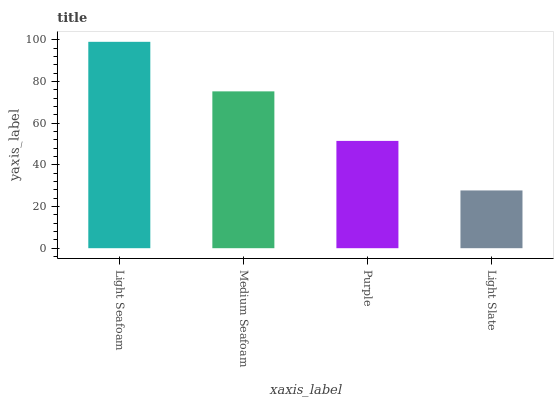Is Light Slate the minimum?
Answer yes or no. Yes. Is Light Seafoam the maximum?
Answer yes or no. Yes. Is Medium Seafoam the minimum?
Answer yes or no. No. Is Medium Seafoam the maximum?
Answer yes or no. No. Is Light Seafoam greater than Medium Seafoam?
Answer yes or no. Yes. Is Medium Seafoam less than Light Seafoam?
Answer yes or no. Yes. Is Medium Seafoam greater than Light Seafoam?
Answer yes or no. No. Is Light Seafoam less than Medium Seafoam?
Answer yes or no. No. Is Medium Seafoam the high median?
Answer yes or no. Yes. Is Purple the low median?
Answer yes or no. Yes. Is Purple the high median?
Answer yes or no. No. Is Medium Seafoam the low median?
Answer yes or no. No. 